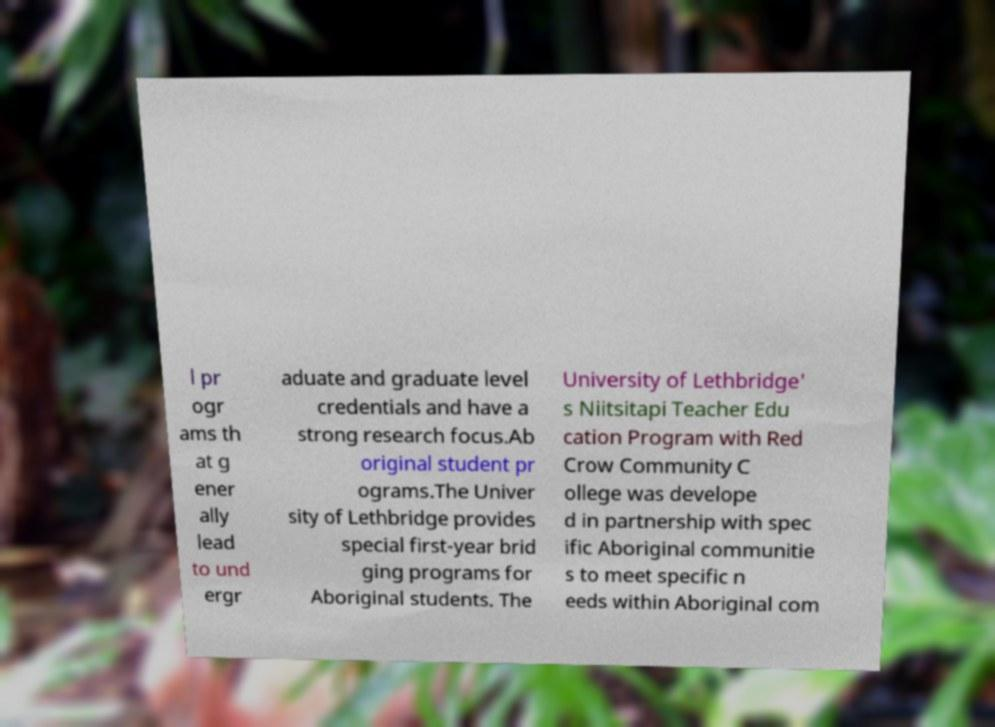What messages or text are displayed in this image? I need them in a readable, typed format. l pr ogr ams th at g ener ally lead to und ergr aduate and graduate level credentials and have a strong research focus.Ab original student pr ograms.The Univer sity of Lethbridge provides special first-year brid ging programs for Aboriginal students. The University of Lethbridge' s Niitsitapi Teacher Edu cation Program with Red Crow Community C ollege was develope d in partnership with spec ific Aboriginal communitie s to meet specific n eeds within Aboriginal com 